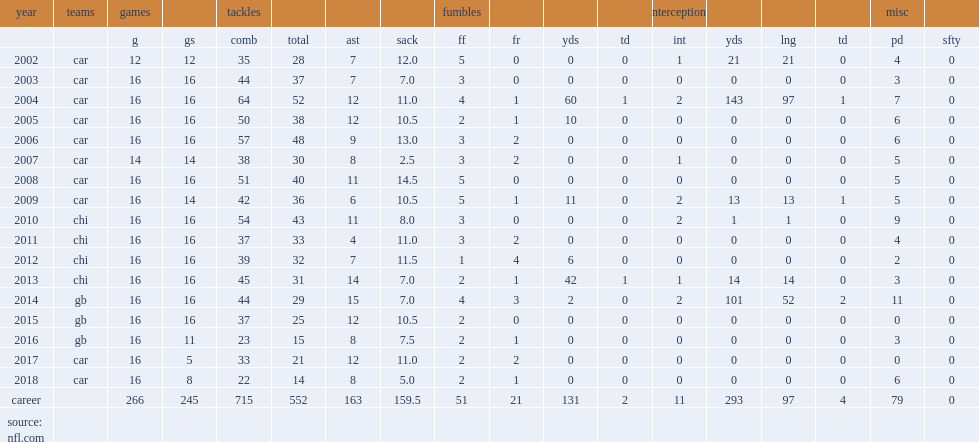How many sacks did peppers record a career-high sacks in the 2008 season? 14.5. 